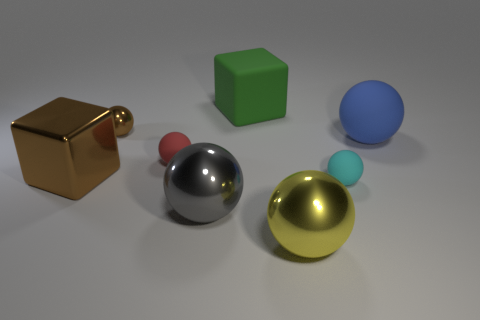Is the color of the small shiny sphere the same as the large cube behind the big blue matte thing?
Keep it short and to the point. No. There is a cube that is the same color as the small metal thing; what material is it?
Provide a succinct answer. Metal. There is a large blue ball; are there any objects to the right of it?
Provide a succinct answer. No. Are there more small cyan balls than large yellow matte blocks?
Your answer should be very brief. Yes. There is a large metallic sphere that is on the right side of the block that is behind the small matte thing that is on the left side of the matte block; what is its color?
Keep it short and to the point. Yellow. The tiny thing that is made of the same material as the brown block is what color?
Give a very brief answer. Brown. Is there any other thing that is the same size as the blue matte object?
Offer a very short reply. Yes. How many things are either small rubber objects that are on the left side of the green block or things on the left side of the gray shiny ball?
Offer a terse response. 3. There is a rubber object that is to the left of the gray object; is its size the same as the brown metallic cube behind the yellow metal sphere?
Your response must be concise. No. The other tiny rubber object that is the same shape as the small red matte object is what color?
Provide a succinct answer. Cyan. 